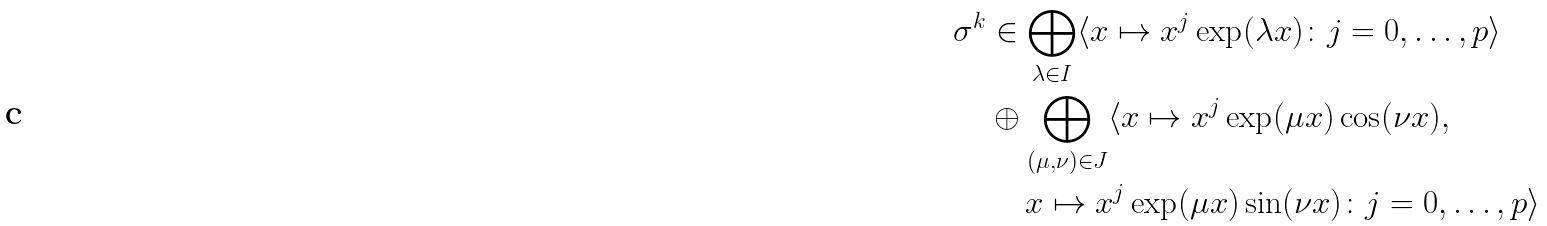Convert formula to latex. <formula><loc_0><loc_0><loc_500><loc_500>\sigma ^ { k } & \in \bigoplus _ { \lambda \in I } \langle x \mapsto x ^ { j } \exp ( \lambda x ) \colon j = 0 , \dots , p \rangle \\ & \oplus \bigoplus _ { ( \mu , \nu ) \in J } \langle x \mapsto x ^ { j } \exp ( \mu x ) \cos ( \nu x ) , \\ & \quad \, x \mapsto x ^ { j } \exp ( \mu x ) \sin ( \nu x ) \colon j = 0 , \dots , p \rangle</formula> 